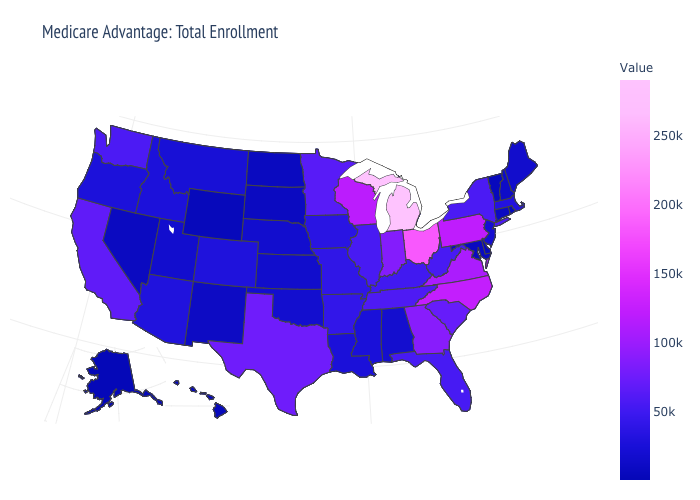Is the legend a continuous bar?
Write a very short answer. Yes. Among the states that border Maryland , does Virginia have the highest value?
Quick response, please. No. Which states have the lowest value in the MidWest?
Write a very short answer. North Dakota. Does Oklahoma have the highest value in the USA?
Keep it brief. No. Which states hav the highest value in the West?
Concise answer only. California. 